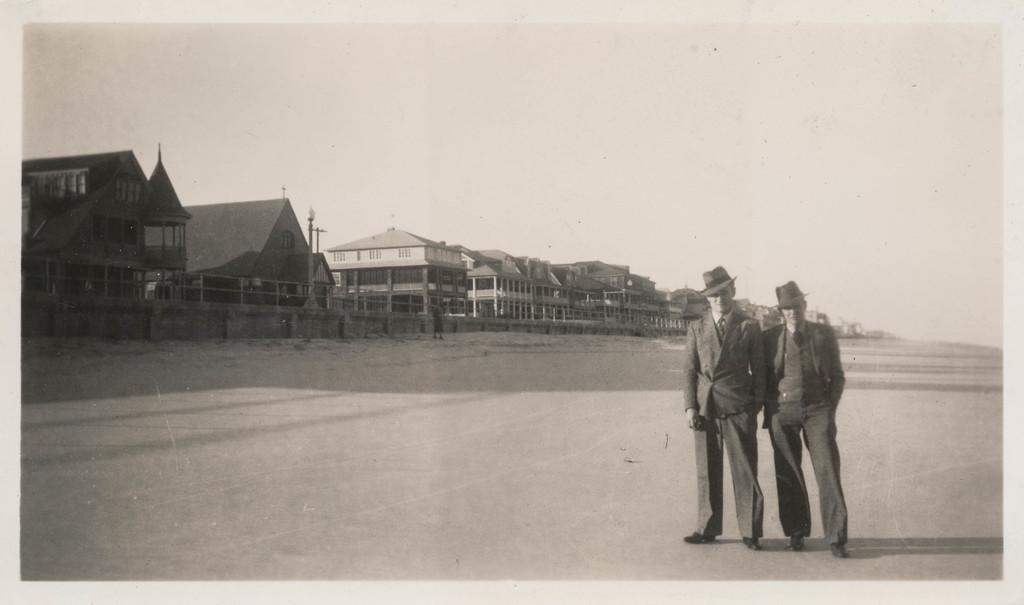How many people are in the image? There are two men in the image. Where are the men located in relation to the image? The men are in the foreground. What can be seen on the left side of the image? There are a lot of houses on the left side of the image. What type of apple is being used to play volleyball in the image? There is no apple or volleyball present in the image. How is the wax being used in the image? There is no wax present in the image. 